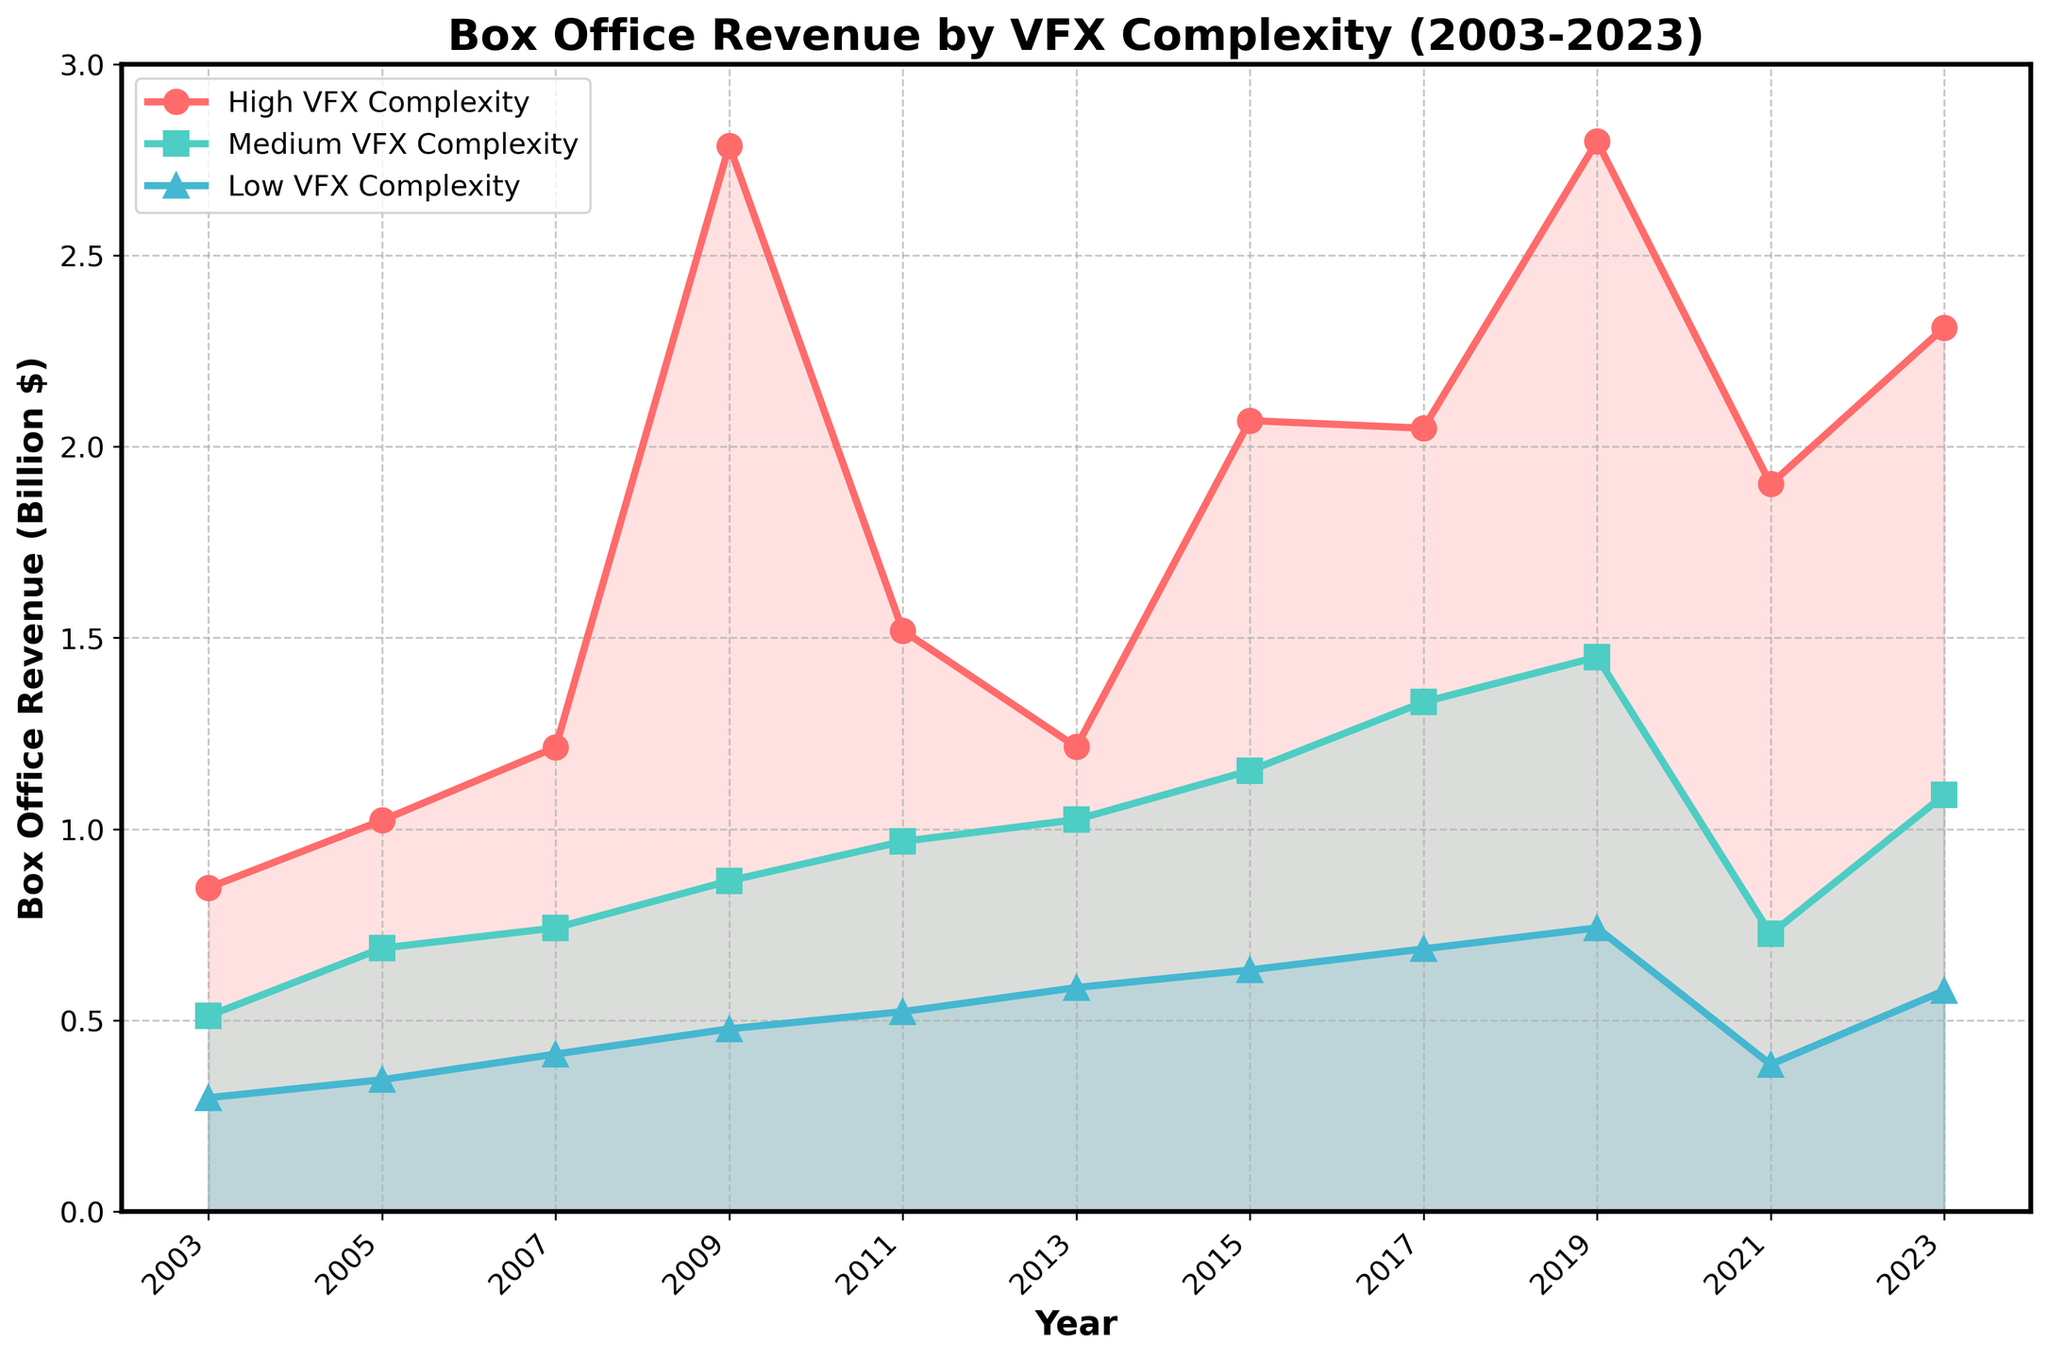What was the highest box office revenue for films with high VFX complexity in the given period? Look at the red line representing high VFX complexity and identify the peak value on the y-axis. The highest point is in 2019 at approximately 2.798 billion dollars.
Answer: 2.798 billion dollars Between which years did films with medium VFX complexity see the most significant increase in box office revenue? Examine the teal line representing medium VFX complexity. The most substantial increase occurs between 2003 and 2005, where the revenue jumps from about 512 million to 689 million dollars.
Answer: 2003-2005 What is the difference in box office revenue for low VFX complexity films between 2017 and 2019? Find the values for low VFX complexity in 2017 and 2019 (687 million and 742 million dollars, respectively). Calculate the difference: 742 million - 687 million = 55 million.
Answer: 55 million dollars What is the trend observed in box office revenues for high VFX complexity films between 2009 and 2021? Evaluate the red line from 2009 to 2021. The trend shows an initial peak in 2009, followed by a decline in 2011, another rise peaking in 2019, and a subsequent decline by 2021.
Answer: Initial peak, decline, rise, peak in 2019, then decline How do the revenues for medium VFX complexity films in 2021 compare to those in 2023? Look for the teal line values in 2021 and 2023. In 2021, the revenue is around 726 million dollars, while in 2023, it is approximately 1.089 billion dollars. The revenue in 2023 is higher.
Answer: Higher in 2023 What color represents the low VFX complexity films in the plot? Identify the color by looking at the legend of the chart. The low VFX complexity films are represented by the blue line.
Answer: Blue What is the average box office revenue for medium VFX complexity films across the given years? Sum up the revenues for medium VFX: (512+689+742+865+968+1025+1153+1332+1450+726+1089) million dollars = 10851 million dollars. Divide by 11 years: 10851/11 ≈ 986 million dollars.
Answer: 986 million dollars Which year saw the lowest box office revenue for low VFX complexity films? Check the blue line for the minimum value on the y-axis. The lowest point is in 2003 at approximately 298 million dollars.
Answer: 2003 How much lower was the revenue for high VFX complexity films in 2021 compared to 2019? Determine the values for high VFX complexity in 2019 and 2021 (2.798 billion and 1.902 billion dollars, respectively). Calculate the difference: 2.798 - 1.902 = 0.896 billion dollars.
Answer: 0.896 billion dollars In which year did the box office revenue for low VFX complexity films first exceed 500 million dollars? Follow the blue line and identify when it first crosses the 500 million dollar mark. This occurs in 2011.
Answer: 2011 